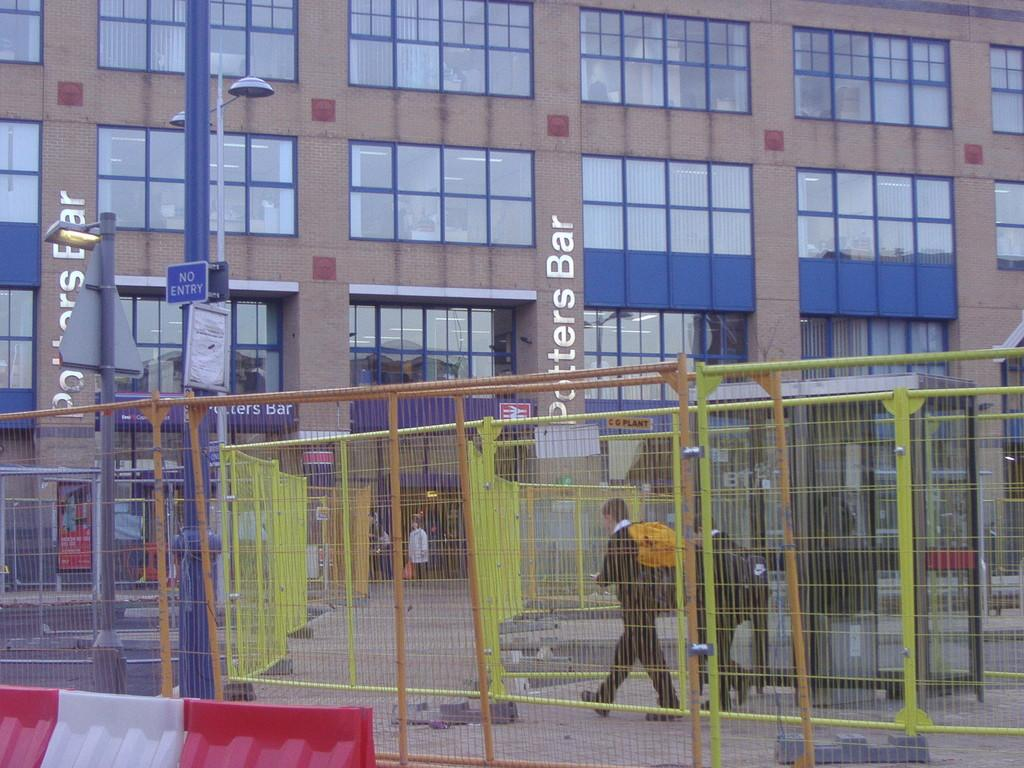What is the person in the image doing? There is a person walking in the image. What surrounds the person as they walk? There is a fence on either side of the person. What can be seen in the distance behind the person? There is a building and a pole in the background of the image. What else can be seen in the background of the image? There are other unspecified objects in the background of the image. What type of coal is being used to fuel the person's fear in the image? There is no coal or fear present in the image; it simply shows a person walking with fences on either side and a background with a building, pole, and other unspecified objects. 